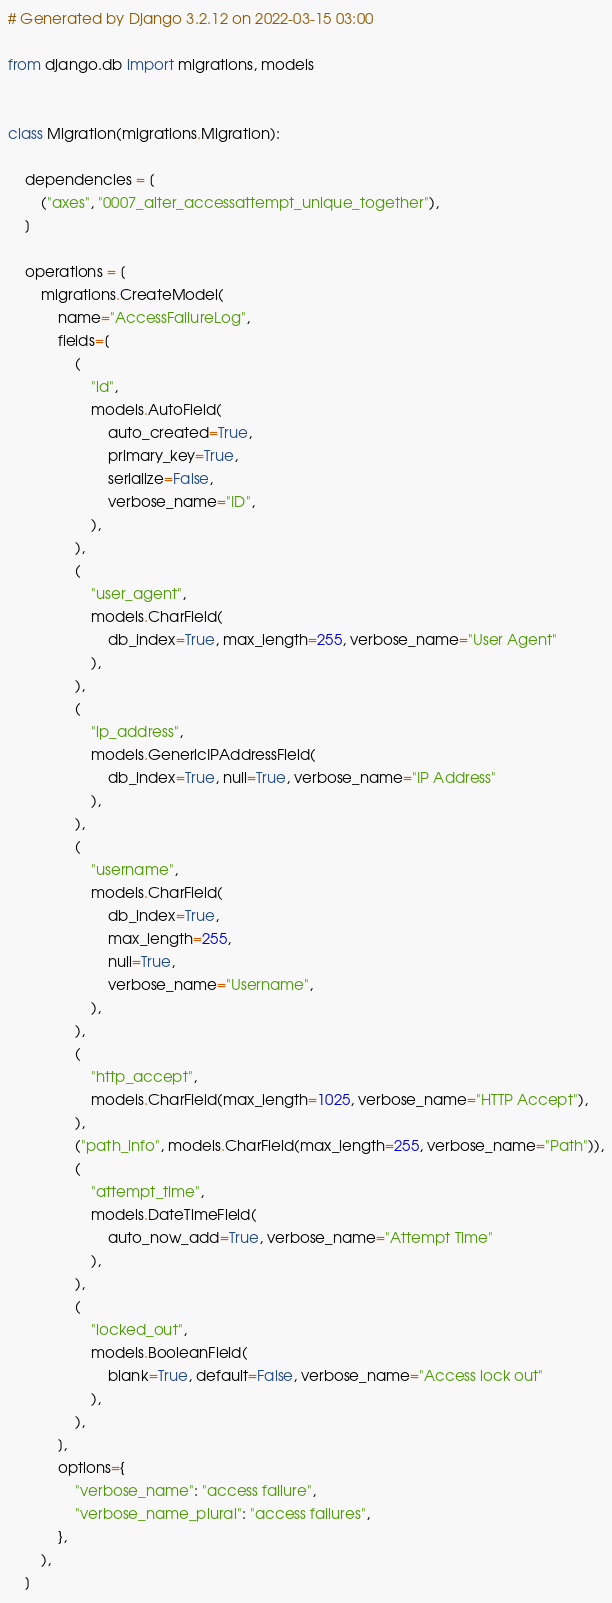<code> <loc_0><loc_0><loc_500><loc_500><_Python_># Generated by Django 3.2.12 on 2022-03-15 03:00

from django.db import migrations, models


class Migration(migrations.Migration):

    dependencies = [
        ("axes", "0007_alter_accessattempt_unique_together"),
    ]

    operations = [
        migrations.CreateModel(
            name="AccessFailureLog",
            fields=[
                (
                    "id",
                    models.AutoField(
                        auto_created=True,
                        primary_key=True,
                        serialize=False,
                        verbose_name="ID",
                    ),
                ),
                (
                    "user_agent",
                    models.CharField(
                        db_index=True, max_length=255, verbose_name="User Agent"
                    ),
                ),
                (
                    "ip_address",
                    models.GenericIPAddressField(
                        db_index=True, null=True, verbose_name="IP Address"
                    ),
                ),
                (
                    "username",
                    models.CharField(
                        db_index=True,
                        max_length=255,
                        null=True,
                        verbose_name="Username",
                    ),
                ),
                (
                    "http_accept",
                    models.CharField(max_length=1025, verbose_name="HTTP Accept"),
                ),
                ("path_info", models.CharField(max_length=255, verbose_name="Path")),
                (
                    "attempt_time",
                    models.DateTimeField(
                        auto_now_add=True, verbose_name="Attempt Time"
                    ),
                ),
                (
                    "locked_out",
                    models.BooleanField(
                        blank=True, default=False, verbose_name="Access lock out"
                    ),
                ),
            ],
            options={
                "verbose_name": "access failure",
                "verbose_name_plural": "access failures",
            },
        ),
    ]
</code> 